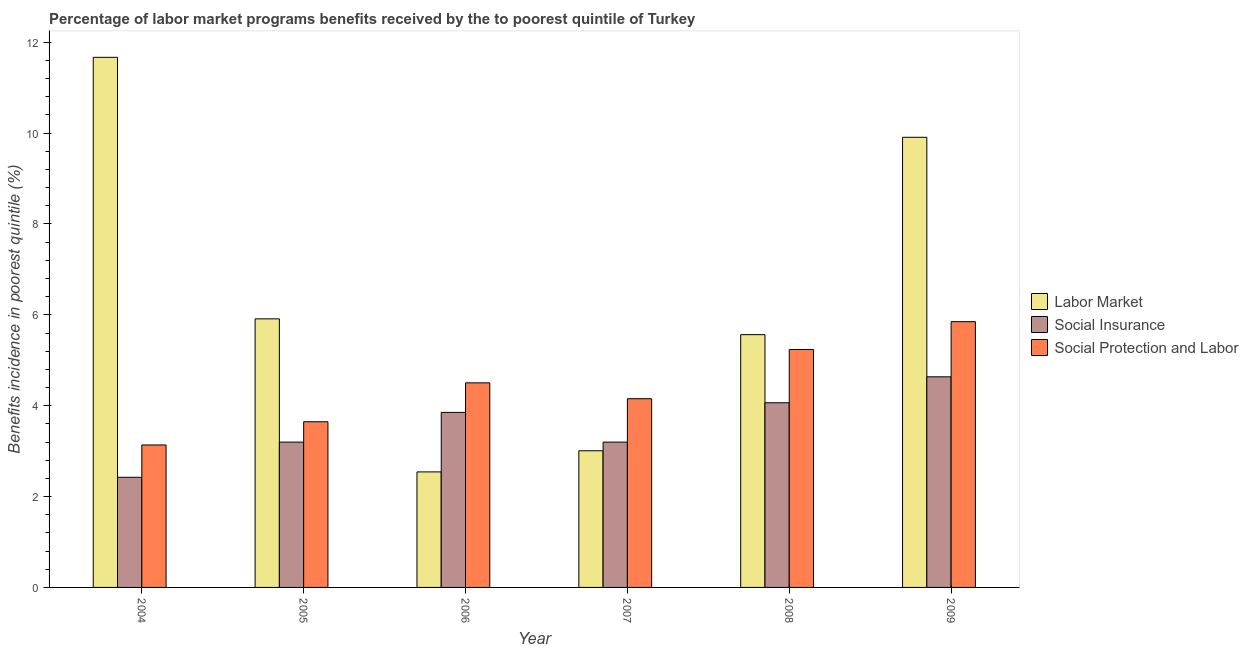How many different coloured bars are there?
Make the answer very short. 3. How many groups of bars are there?
Offer a very short reply. 6. Are the number of bars per tick equal to the number of legend labels?
Offer a terse response. Yes. In how many cases, is the number of bars for a given year not equal to the number of legend labels?
Your answer should be compact. 0. What is the percentage of benefits received due to social protection programs in 2006?
Provide a succinct answer. 4.5. Across all years, what is the maximum percentage of benefits received due to social protection programs?
Your response must be concise. 5.85. Across all years, what is the minimum percentage of benefits received due to labor market programs?
Your answer should be compact. 2.54. In which year was the percentage of benefits received due to social protection programs minimum?
Offer a terse response. 2004. What is the total percentage of benefits received due to labor market programs in the graph?
Provide a succinct answer. 38.6. What is the difference between the percentage of benefits received due to labor market programs in 2008 and that in 2009?
Provide a short and direct response. -4.34. What is the difference between the percentage of benefits received due to social insurance programs in 2006 and the percentage of benefits received due to social protection programs in 2005?
Keep it short and to the point. 0.65. What is the average percentage of benefits received due to social insurance programs per year?
Provide a succinct answer. 3.56. In the year 2006, what is the difference between the percentage of benefits received due to social insurance programs and percentage of benefits received due to social protection programs?
Your answer should be compact. 0. What is the ratio of the percentage of benefits received due to social protection programs in 2005 to that in 2006?
Make the answer very short. 0.81. Is the percentage of benefits received due to social insurance programs in 2006 less than that in 2007?
Provide a short and direct response. No. Is the difference between the percentage of benefits received due to social protection programs in 2005 and 2009 greater than the difference between the percentage of benefits received due to labor market programs in 2005 and 2009?
Keep it short and to the point. No. What is the difference between the highest and the second highest percentage of benefits received due to labor market programs?
Keep it short and to the point. 1.76. What is the difference between the highest and the lowest percentage of benefits received due to social protection programs?
Your response must be concise. 2.71. In how many years, is the percentage of benefits received due to social insurance programs greater than the average percentage of benefits received due to social insurance programs taken over all years?
Provide a short and direct response. 3. Is the sum of the percentage of benefits received due to social insurance programs in 2008 and 2009 greater than the maximum percentage of benefits received due to social protection programs across all years?
Offer a terse response. Yes. What does the 1st bar from the left in 2005 represents?
Give a very brief answer. Labor Market. What does the 3rd bar from the right in 2004 represents?
Your answer should be compact. Labor Market. Does the graph contain any zero values?
Your answer should be compact. No. Does the graph contain grids?
Your response must be concise. No. Where does the legend appear in the graph?
Make the answer very short. Center right. How many legend labels are there?
Keep it short and to the point. 3. What is the title of the graph?
Keep it short and to the point. Percentage of labor market programs benefits received by the to poorest quintile of Turkey. What is the label or title of the Y-axis?
Your answer should be very brief. Benefits incidence in poorest quintile (%). What is the Benefits incidence in poorest quintile (%) of Labor Market in 2004?
Provide a succinct answer. 11.67. What is the Benefits incidence in poorest quintile (%) in Social Insurance in 2004?
Ensure brevity in your answer.  2.42. What is the Benefits incidence in poorest quintile (%) of Social Protection and Labor in 2004?
Offer a very short reply. 3.14. What is the Benefits incidence in poorest quintile (%) of Labor Market in 2005?
Your answer should be compact. 5.91. What is the Benefits incidence in poorest quintile (%) in Social Insurance in 2005?
Offer a very short reply. 3.2. What is the Benefits incidence in poorest quintile (%) of Social Protection and Labor in 2005?
Make the answer very short. 3.65. What is the Benefits incidence in poorest quintile (%) in Labor Market in 2006?
Provide a short and direct response. 2.54. What is the Benefits incidence in poorest quintile (%) in Social Insurance in 2006?
Offer a very short reply. 3.85. What is the Benefits incidence in poorest quintile (%) in Social Protection and Labor in 2006?
Make the answer very short. 4.5. What is the Benefits incidence in poorest quintile (%) of Labor Market in 2007?
Provide a succinct answer. 3.01. What is the Benefits incidence in poorest quintile (%) in Social Insurance in 2007?
Offer a terse response. 3.2. What is the Benefits incidence in poorest quintile (%) of Social Protection and Labor in 2007?
Keep it short and to the point. 4.15. What is the Benefits incidence in poorest quintile (%) in Labor Market in 2008?
Provide a succinct answer. 5.56. What is the Benefits incidence in poorest quintile (%) of Social Insurance in 2008?
Offer a very short reply. 4.06. What is the Benefits incidence in poorest quintile (%) in Social Protection and Labor in 2008?
Give a very brief answer. 5.24. What is the Benefits incidence in poorest quintile (%) of Labor Market in 2009?
Offer a terse response. 9.91. What is the Benefits incidence in poorest quintile (%) in Social Insurance in 2009?
Offer a very short reply. 4.64. What is the Benefits incidence in poorest quintile (%) in Social Protection and Labor in 2009?
Provide a short and direct response. 5.85. Across all years, what is the maximum Benefits incidence in poorest quintile (%) of Labor Market?
Your answer should be compact. 11.67. Across all years, what is the maximum Benefits incidence in poorest quintile (%) in Social Insurance?
Provide a short and direct response. 4.64. Across all years, what is the maximum Benefits incidence in poorest quintile (%) of Social Protection and Labor?
Offer a very short reply. 5.85. Across all years, what is the minimum Benefits incidence in poorest quintile (%) in Labor Market?
Offer a very short reply. 2.54. Across all years, what is the minimum Benefits incidence in poorest quintile (%) in Social Insurance?
Your answer should be compact. 2.42. Across all years, what is the minimum Benefits incidence in poorest quintile (%) of Social Protection and Labor?
Ensure brevity in your answer.  3.14. What is the total Benefits incidence in poorest quintile (%) of Labor Market in the graph?
Ensure brevity in your answer.  38.6. What is the total Benefits incidence in poorest quintile (%) in Social Insurance in the graph?
Your answer should be very brief. 21.37. What is the total Benefits incidence in poorest quintile (%) in Social Protection and Labor in the graph?
Provide a succinct answer. 26.53. What is the difference between the Benefits incidence in poorest quintile (%) of Labor Market in 2004 and that in 2005?
Ensure brevity in your answer.  5.76. What is the difference between the Benefits incidence in poorest quintile (%) of Social Insurance in 2004 and that in 2005?
Give a very brief answer. -0.77. What is the difference between the Benefits incidence in poorest quintile (%) of Social Protection and Labor in 2004 and that in 2005?
Ensure brevity in your answer.  -0.51. What is the difference between the Benefits incidence in poorest quintile (%) in Labor Market in 2004 and that in 2006?
Make the answer very short. 9.13. What is the difference between the Benefits incidence in poorest quintile (%) in Social Insurance in 2004 and that in 2006?
Offer a very short reply. -1.43. What is the difference between the Benefits incidence in poorest quintile (%) of Social Protection and Labor in 2004 and that in 2006?
Ensure brevity in your answer.  -1.37. What is the difference between the Benefits incidence in poorest quintile (%) of Labor Market in 2004 and that in 2007?
Make the answer very short. 8.66. What is the difference between the Benefits incidence in poorest quintile (%) in Social Insurance in 2004 and that in 2007?
Your answer should be very brief. -0.77. What is the difference between the Benefits incidence in poorest quintile (%) of Social Protection and Labor in 2004 and that in 2007?
Keep it short and to the point. -1.02. What is the difference between the Benefits incidence in poorest quintile (%) of Labor Market in 2004 and that in 2008?
Provide a short and direct response. 6.11. What is the difference between the Benefits incidence in poorest quintile (%) in Social Insurance in 2004 and that in 2008?
Provide a short and direct response. -1.64. What is the difference between the Benefits incidence in poorest quintile (%) in Social Protection and Labor in 2004 and that in 2008?
Your answer should be very brief. -2.1. What is the difference between the Benefits incidence in poorest quintile (%) of Labor Market in 2004 and that in 2009?
Offer a terse response. 1.76. What is the difference between the Benefits incidence in poorest quintile (%) in Social Insurance in 2004 and that in 2009?
Provide a succinct answer. -2.21. What is the difference between the Benefits incidence in poorest quintile (%) in Social Protection and Labor in 2004 and that in 2009?
Keep it short and to the point. -2.71. What is the difference between the Benefits incidence in poorest quintile (%) of Labor Market in 2005 and that in 2006?
Keep it short and to the point. 3.37. What is the difference between the Benefits incidence in poorest quintile (%) in Social Insurance in 2005 and that in 2006?
Make the answer very short. -0.65. What is the difference between the Benefits incidence in poorest quintile (%) of Social Protection and Labor in 2005 and that in 2006?
Ensure brevity in your answer.  -0.86. What is the difference between the Benefits incidence in poorest quintile (%) in Labor Market in 2005 and that in 2007?
Your answer should be very brief. 2.9. What is the difference between the Benefits incidence in poorest quintile (%) in Social Insurance in 2005 and that in 2007?
Ensure brevity in your answer.  0. What is the difference between the Benefits incidence in poorest quintile (%) in Social Protection and Labor in 2005 and that in 2007?
Offer a very short reply. -0.51. What is the difference between the Benefits incidence in poorest quintile (%) of Labor Market in 2005 and that in 2008?
Offer a very short reply. 0.35. What is the difference between the Benefits incidence in poorest quintile (%) of Social Insurance in 2005 and that in 2008?
Make the answer very short. -0.87. What is the difference between the Benefits incidence in poorest quintile (%) of Social Protection and Labor in 2005 and that in 2008?
Give a very brief answer. -1.59. What is the difference between the Benefits incidence in poorest quintile (%) of Labor Market in 2005 and that in 2009?
Your answer should be compact. -4. What is the difference between the Benefits incidence in poorest quintile (%) of Social Insurance in 2005 and that in 2009?
Give a very brief answer. -1.44. What is the difference between the Benefits incidence in poorest quintile (%) in Social Protection and Labor in 2005 and that in 2009?
Keep it short and to the point. -2.2. What is the difference between the Benefits incidence in poorest quintile (%) of Labor Market in 2006 and that in 2007?
Give a very brief answer. -0.46. What is the difference between the Benefits incidence in poorest quintile (%) of Social Insurance in 2006 and that in 2007?
Make the answer very short. 0.65. What is the difference between the Benefits incidence in poorest quintile (%) in Social Protection and Labor in 2006 and that in 2007?
Give a very brief answer. 0.35. What is the difference between the Benefits incidence in poorest quintile (%) in Labor Market in 2006 and that in 2008?
Your response must be concise. -3.02. What is the difference between the Benefits incidence in poorest quintile (%) in Social Insurance in 2006 and that in 2008?
Ensure brevity in your answer.  -0.21. What is the difference between the Benefits incidence in poorest quintile (%) in Social Protection and Labor in 2006 and that in 2008?
Make the answer very short. -0.73. What is the difference between the Benefits incidence in poorest quintile (%) of Labor Market in 2006 and that in 2009?
Provide a succinct answer. -7.37. What is the difference between the Benefits incidence in poorest quintile (%) of Social Insurance in 2006 and that in 2009?
Ensure brevity in your answer.  -0.78. What is the difference between the Benefits incidence in poorest quintile (%) of Social Protection and Labor in 2006 and that in 2009?
Your answer should be very brief. -1.35. What is the difference between the Benefits incidence in poorest quintile (%) of Labor Market in 2007 and that in 2008?
Ensure brevity in your answer.  -2.56. What is the difference between the Benefits incidence in poorest quintile (%) in Social Insurance in 2007 and that in 2008?
Keep it short and to the point. -0.87. What is the difference between the Benefits incidence in poorest quintile (%) in Social Protection and Labor in 2007 and that in 2008?
Keep it short and to the point. -1.08. What is the difference between the Benefits incidence in poorest quintile (%) in Labor Market in 2007 and that in 2009?
Give a very brief answer. -6.9. What is the difference between the Benefits incidence in poorest quintile (%) of Social Insurance in 2007 and that in 2009?
Your response must be concise. -1.44. What is the difference between the Benefits incidence in poorest quintile (%) of Social Protection and Labor in 2007 and that in 2009?
Offer a very short reply. -1.7. What is the difference between the Benefits incidence in poorest quintile (%) in Labor Market in 2008 and that in 2009?
Your answer should be very brief. -4.34. What is the difference between the Benefits incidence in poorest quintile (%) in Social Insurance in 2008 and that in 2009?
Your response must be concise. -0.57. What is the difference between the Benefits incidence in poorest quintile (%) of Social Protection and Labor in 2008 and that in 2009?
Provide a succinct answer. -0.61. What is the difference between the Benefits incidence in poorest quintile (%) of Labor Market in 2004 and the Benefits incidence in poorest quintile (%) of Social Insurance in 2005?
Provide a succinct answer. 8.47. What is the difference between the Benefits incidence in poorest quintile (%) in Labor Market in 2004 and the Benefits incidence in poorest quintile (%) in Social Protection and Labor in 2005?
Keep it short and to the point. 8.02. What is the difference between the Benefits incidence in poorest quintile (%) in Social Insurance in 2004 and the Benefits incidence in poorest quintile (%) in Social Protection and Labor in 2005?
Offer a very short reply. -1.22. What is the difference between the Benefits incidence in poorest quintile (%) of Labor Market in 2004 and the Benefits incidence in poorest quintile (%) of Social Insurance in 2006?
Keep it short and to the point. 7.82. What is the difference between the Benefits incidence in poorest quintile (%) in Labor Market in 2004 and the Benefits incidence in poorest quintile (%) in Social Protection and Labor in 2006?
Your answer should be compact. 7.17. What is the difference between the Benefits incidence in poorest quintile (%) in Social Insurance in 2004 and the Benefits incidence in poorest quintile (%) in Social Protection and Labor in 2006?
Provide a short and direct response. -2.08. What is the difference between the Benefits incidence in poorest quintile (%) of Labor Market in 2004 and the Benefits incidence in poorest quintile (%) of Social Insurance in 2007?
Your response must be concise. 8.47. What is the difference between the Benefits incidence in poorest quintile (%) in Labor Market in 2004 and the Benefits incidence in poorest quintile (%) in Social Protection and Labor in 2007?
Your answer should be compact. 7.51. What is the difference between the Benefits incidence in poorest quintile (%) in Social Insurance in 2004 and the Benefits incidence in poorest quintile (%) in Social Protection and Labor in 2007?
Keep it short and to the point. -1.73. What is the difference between the Benefits incidence in poorest quintile (%) in Labor Market in 2004 and the Benefits incidence in poorest quintile (%) in Social Insurance in 2008?
Ensure brevity in your answer.  7.6. What is the difference between the Benefits incidence in poorest quintile (%) of Labor Market in 2004 and the Benefits incidence in poorest quintile (%) of Social Protection and Labor in 2008?
Make the answer very short. 6.43. What is the difference between the Benefits incidence in poorest quintile (%) of Social Insurance in 2004 and the Benefits incidence in poorest quintile (%) of Social Protection and Labor in 2008?
Ensure brevity in your answer.  -2.81. What is the difference between the Benefits incidence in poorest quintile (%) of Labor Market in 2004 and the Benefits incidence in poorest quintile (%) of Social Insurance in 2009?
Provide a succinct answer. 7.03. What is the difference between the Benefits incidence in poorest quintile (%) in Labor Market in 2004 and the Benefits incidence in poorest quintile (%) in Social Protection and Labor in 2009?
Provide a succinct answer. 5.82. What is the difference between the Benefits incidence in poorest quintile (%) in Social Insurance in 2004 and the Benefits incidence in poorest quintile (%) in Social Protection and Labor in 2009?
Your answer should be compact. -3.43. What is the difference between the Benefits incidence in poorest quintile (%) in Labor Market in 2005 and the Benefits incidence in poorest quintile (%) in Social Insurance in 2006?
Provide a short and direct response. 2.06. What is the difference between the Benefits incidence in poorest quintile (%) in Labor Market in 2005 and the Benefits incidence in poorest quintile (%) in Social Protection and Labor in 2006?
Your answer should be very brief. 1.41. What is the difference between the Benefits incidence in poorest quintile (%) in Social Insurance in 2005 and the Benefits incidence in poorest quintile (%) in Social Protection and Labor in 2006?
Ensure brevity in your answer.  -1.3. What is the difference between the Benefits incidence in poorest quintile (%) in Labor Market in 2005 and the Benefits incidence in poorest quintile (%) in Social Insurance in 2007?
Your response must be concise. 2.71. What is the difference between the Benefits incidence in poorest quintile (%) of Labor Market in 2005 and the Benefits incidence in poorest quintile (%) of Social Protection and Labor in 2007?
Ensure brevity in your answer.  1.76. What is the difference between the Benefits incidence in poorest quintile (%) in Social Insurance in 2005 and the Benefits incidence in poorest quintile (%) in Social Protection and Labor in 2007?
Your answer should be very brief. -0.96. What is the difference between the Benefits incidence in poorest quintile (%) in Labor Market in 2005 and the Benefits incidence in poorest quintile (%) in Social Insurance in 2008?
Provide a short and direct response. 1.85. What is the difference between the Benefits incidence in poorest quintile (%) in Labor Market in 2005 and the Benefits incidence in poorest quintile (%) in Social Protection and Labor in 2008?
Provide a short and direct response. 0.68. What is the difference between the Benefits incidence in poorest quintile (%) in Social Insurance in 2005 and the Benefits incidence in poorest quintile (%) in Social Protection and Labor in 2008?
Provide a succinct answer. -2.04. What is the difference between the Benefits incidence in poorest quintile (%) in Labor Market in 2005 and the Benefits incidence in poorest quintile (%) in Social Insurance in 2009?
Provide a short and direct response. 1.28. What is the difference between the Benefits incidence in poorest quintile (%) of Labor Market in 2005 and the Benefits incidence in poorest quintile (%) of Social Protection and Labor in 2009?
Provide a succinct answer. 0.06. What is the difference between the Benefits incidence in poorest quintile (%) in Social Insurance in 2005 and the Benefits incidence in poorest quintile (%) in Social Protection and Labor in 2009?
Ensure brevity in your answer.  -2.65. What is the difference between the Benefits incidence in poorest quintile (%) of Labor Market in 2006 and the Benefits incidence in poorest quintile (%) of Social Insurance in 2007?
Offer a very short reply. -0.66. What is the difference between the Benefits incidence in poorest quintile (%) in Labor Market in 2006 and the Benefits incidence in poorest quintile (%) in Social Protection and Labor in 2007?
Ensure brevity in your answer.  -1.61. What is the difference between the Benefits incidence in poorest quintile (%) in Social Insurance in 2006 and the Benefits incidence in poorest quintile (%) in Social Protection and Labor in 2007?
Offer a very short reply. -0.3. What is the difference between the Benefits incidence in poorest quintile (%) in Labor Market in 2006 and the Benefits incidence in poorest quintile (%) in Social Insurance in 2008?
Provide a succinct answer. -1.52. What is the difference between the Benefits incidence in poorest quintile (%) of Labor Market in 2006 and the Benefits incidence in poorest quintile (%) of Social Protection and Labor in 2008?
Your response must be concise. -2.69. What is the difference between the Benefits incidence in poorest quintile (%) of Social Insurance in 2006 and the Benefits incidence in poorest quintile (%) of Social Protection and Labor in 2008?
Ensure brevity in your answer.  -1.38. What is the difference between the Benefits incidence in poorest quintile (%) in Labor Market in 2006 and the Benefits incidence in poorest quintile (%) in Social Insurance in 2009?
Give a very brief answer. -2.09. What is the difference between the Benefits incidence in poorest quintile (%) of Labor Market in 2006 and the Benefits incidence in poorest quintile (%) of Social Protection and Labor in 2009?
Your answer should be compact. -3.31. What is the difference between the Benefits incidence in poorest quintile (%) of Social Insurance in 2006 and the Benefits incidence in poorest quintile (%) of Social Protection and Labor in 2009?
Keep it short and to the point. -2. What is the difference between the Benefits incidence in poorest quintile (%) of Labor Market in 2007 and the Benefits incidence in poorest quintile (%) of Social Insurance in 2008?
Give a very brief answer. -1.06. What is the difference between the Benefits incidence in poorest quintile (%) of Labor Market in 2007 and the Benefits incidence in poorest quintile (%) of Social Protection and Labor in 2008?
Your response must be concise. -2.23. What is the difference between the Benefits incidence in poorest quintile (%) of Social Insurance in 2007 and the Benefits incidence in poorest quintile (%) of Social Protection and Labor in 2008?
Provide a succinct answer. -2.04. What is the difference between the Benefits incidence in poorest quintile (%) in Labor Market in 2007 and the Benefits incidence in poorest quintile (%) in Social Insurance in 2009?
Your answer should be compact. -1.63. What is the difference between the Benefits incidence in poorest quintile (%) in Labor Market in 2007 and the Benefits incidence in poorest quintile (%) in Social Protection and Labor in 2009?
Offer a terse response. -2.84. What is the difference between the Benefits incidence in poorest quintile (%) in Social Insurance in 2007 and the Benefits incidence in poorest quintile (%) in Social Protection and Labor in 2009?
Your answer should be compact. -2.65. What is the difference between the Benefits incidence in poorest quintile (%) in Labor Market in 2008 and the Benefits incidence in poorest quintile (%) in Social Insurance in 2009?
Your answer should be very brief. 0.93. What is the difference between the Benefits incidence in poorest quintile (%) in Labor Market in 2008 and the Benefits incidence in poorest quintile (%) in Social Protection and Labor in 2009?
Provide a short and direct response. -0.29. What is the difference between the Benefits incidence in poorest quintile (%) of Social Insurance in 2008 and the Benefits incidence in poorest quintile (%) of Social Protection and Labor in 2009?
Ensure brevity in your answer.  -1.79. What is the average Benefits incidence in poorest quintile (%) of Labor Market per year?
Give a very brief answer. 6.43. What is the average Benefits incidence in poorest quintile (%) of Social Insurance per year?
Make the answer very short. 3.56. What is the average Benefits incidence in poorest quintile (%) of Social Protection and Labor per year?
Your response must be concise. 4.42. In the year 2004, what is the difference between the Benefits incidence in poorest quintile (%) of Labor Market and Benefits incidence in poorest quintile (%) of Social Insurance?
Ensure brevity in your answer.  9.24. In the year 2004, what is the difference between the Benefits incidence in poorest quintile (%) of Labor Market and Benefits incidence in poorest quintile (%) of Social Protection and Labor?
Give a very brief answer. 8.53. In the year 2004, what is the difference between the Benefits incidence in poorest quintile (%) of Social Insurance and Benefits incidence in poorest quintile (%) of Social Protection and Labor?
Ensure brevity in your answer.  -0.71. In the year 2005, what is the difference between the Benefits incidence in poorest quintile (%) in Labor Market and Benefits incidence in poorest quintile (%) in Social Insurance?
Make the answer very short. 2.71. In the year 2005, what is the difference between the Benefits incidence in poorest quintile (%) in Labor Market and Benefits incidence in poorest quintile (%) in Social Protection and Labor?
Your answer should be compact. 2.27. In the year 2005, what is the difference between the Benefits incidence in poorest quintile (%) in Social Insurance and Benefits incidence in poorest quintile (%) in Social Protection and Labor?
Provide a short and direct response. -0.45. In the year 2006, what is the difference between the Benefits incidence in poorest quintile (%) in Labor Market and Benefits incidence in poorest quintile (%) in Social Insurance?
Your response must be concise. -1.31. In the year 2006, what is the difference between the Benefits incidence in poorest quintile (%) in Labor Market and Benefits incidence in poorest quintile (%) in Social Protection and Labor?
Provide a short and direct response. -1.96. In the year 2006, what is the difference between the Benefits incidence in poorest quintile (%) in Social Insurance and Benefits incidence in poorest quintile (%) in Social Protection and Labor?
Give a very brief answer. -0.65. In the year 2007, what is the difference between the Benefits incidence in poorest quintile (%) of Labor Market and Benefits incidence in poorest quintile (%) of Social Insurance?
Provide a succinct answer. -0.19. In the year 2007, what is the difference between the Benefits incidence in poorest quintile (%) of Labor Market and Benefits incidence in poorest quintile (%) of Social Protection and Labor?
Keep it short and to the point. -1.15. In the year 2007, what is the difference between the Benefits incidence in poorest quintile (%) in Social Insurance and Benefits incidence in poorest quintile (%) in Social Protection and Labor?
Provide a succinct answer. -0.96. In the year 2008, what is the difference between the Benefits incidence in poorest quintile (%) of Labor Market and Benefits incidence in poorest quintile (%) of Social Insurance?
Ensure brevity in your answer.  1.5. In the year 2008, what is the difference between the Benefits incidence in poorest quintile (%) in Labor Market and Benefits incidence in poorest quintile (%) in Social Protection and Labor?
Provide a succinct answer. 0.33. In the year 2008, what is the difference between the Benefits incidence in poorest quintile (%) of Social Insurance and Benefits incidence in poorest quintile (%) of Social Protection and Labor?
Your answer should be very brief. -1.17. In the year 2009, what is the difference between the Benefits incidence in poorest quintile (%) of Labor Market and Benefits incidence in poorest quintile (%) of Social Insurance?
Give a very brief answer. 5.27. In the year 2009, what is the difference between the Benefits incidence in poorest quintile (%) of Labor Market and Benefits incidence in poorest quintile (%) of Social Protection and Labor?
Your answer should be very brief. 4.06. In the year 2009, what is the difference between the Benefits incidence in poorest quintile (%) in Social Insurance and Benefits incidence in poorest quintile (%) in Social Protection and Labor?
Ensure brevity in your answer.  -1.21. What is the ratio of the Benefits incidence in poorest quintile (%) of Labor Market in 2004 to that in 2005?
Your response must be concise. 1.97. What is the ratio of the Benefits incidence in poorest quintile (%) in Social Insurance in 2004 to that in 2005?
Your answer should be compact. 0.76. What is the ratio of the Benefits incidence in poorest quintile (%) of Social Protection and Labor in 2004 to that in 2005?
Provide a succinct answer. 0.86. What is the ratio of the Benefits incidence in poorest quintile (%) in Labor Market in 2004 to that in 2006?
Keep it short and to the point. 4.59. What is the ratio of the Benefits incidence in poorest quintile (%) of Social Insurance in 2004 to that in 2006?
Offer a very short reply. 0.63. What is the ratio of the Benefits incidence in poorest quintile (%) in Social Protection and Labor in 2004 to that in 2006?
Your answer should be compact. 0.7. What is the ratio of the Benefits incidence in poorest quintile (%) in Labor Market in 2004 to that in 2007?
Give a very brief answer. 3.88. What is the ratio of the Benefits incidence in poorest quintile (%) of Social Insurance in 2004 to that in 2007?
Your answer should be compact. 0.76. What is the ratio of the Benefits incidence in poorest quintile (%) in Social Protection and Labor in 2004 to that in 2007?
Provide a short and direct response. 0.76. What is the ratio of the Benefits incidence in poorest quintile (%) of Labor Market in 2004 to that in 2008?
Provide a succinct answer. 2.1. What is the ratio of the Benefits incidence in poorest quintile (%) in Social Insurance in 2004 to that in 2008?
Your answer should be very brief. 0.6. What is the ratio of the Benefits incidence in poorest quintile (%) in Social Protection and Labor in 2004 to that in 2008?
Keep it short and to the point. 0.6. What is the ratio of the Benefits incidence in poorest quintile (%) in Labor Market in 2004 to that in 2009?
Make the answer very short. 1.18. What is the ratio of the Benefits incidence in poorest quintile (%) in Social Insurance in 2004 to that in 2009?
Keep it short and to the point. 0.52. What is the ratio of the Benefits incidence in poorest quintile (%) in Social Protection and Labor in 2004 to that in 2009?
Your response must be concise. 0.54. What is the ratio of the Benefits incidence in poorest quintile (%) of Labor Market in 2005 to that in 2006?
Provide a succinct answer. 2.32. What is the ratio of the Benefits incidence in poorest quintile (%) in Social Insurance in 2005 to that in 2006?
Offer a terse response. 0.83. What is the ratio of the Benefits incidence in poorest quintile (%) in Social Protection and Labor in 2005 to that in 2006?
Offer a terse response. 0.81. What is the ratio of the Benefits incidence in poorest quintile (%) of Labor Market in 2005 to that in 2007?
Your response must be concise. 1.97. What is the ratio of the Benefits incidence in poorest quintile (%) in Social Insurance in 2005 to that in 2007?
Provide a succinct answer. 1. What is the ratio of the Benefits incidence in poorest quintile (%) in Social Protection and Labor in 2005 to that in 2007?
Offer a terse response. 0.88. What is the ratio of the Benefits incidence in poorest quintile (%) of Labor Market in 2005 to that in 2008?
Give a very brief answer. 1.06. What is the ratio of the Benefits incidence in poorest quintile (%) of Social Insurance in 2005 to that in 2008?
Provide a short and direct response. 0.79. What is the ratio of the Benefits incidence in poorest quintile (%) of Social Protection and Labor in 2005 to that in 2008?
Provide a succinct answer. 0.7. What is the ratio of the Benefits incidence in poorest quintile (%) of Labor Market in 2005 to that in 2009?
Ensure brevity in your answer.  0.6. What is the ratio of the Benefits incidence in poorest quintile (%) of Social Insurance in 2005 to that in 2009?
Offer a terse response. 0.69. What is the ratio of the Benefits incidence in poorest quintile (%) in Social Protection and Labor in 2005 to that in 2009?
Keep it short and to the point. 0.62. What is the ratio of the Benefits incidence in poorest quintile (%) of Labor Market in 2006 to that in 2007?
Provide a succinct answer. 0.85. What is the ratio of the Benefits incidence in poorest quintile (%) of Social Insurance in 2006 to that in 2007?
Your answer should be very brief. 1.2. What is the ratio of the Benefits incidence in poorest quintile (%) in Social Protection and Labor in 2006 to that in 2007?
Offer a very short reply. 1.08. What is the ratio of the Benefits incidence in poorest quintile (%) in Labor Market in 2006 to that in 2008?
Give a very brief answer. 0.46. What is the ratio of the Benefits incidence in poorest quintile (%) of Social Insurance in 2006 to that in 2008?
Ensure brevity in your answer.  0.95. What is the ratio of the Benefits incidence in poorest quintile (%) of Social Protection and Labor in 2006 to that in 2008?
Your response must be concise. 0.86. What is the ratio of the Benefits incidence in poorest quintile (%) in Labor Market in 2006 to that in 2009?
Offer a terse response. 0.26. What is the ratio of the Benefits incidence in poorest quintile (%) in Social Insurance in 2006 to that in 2009?
Offer a terse response. 0.83. What is the ratio of the Benefits incidence in poorest quintile (%) in Social Protection and Labor in 2006 to that in 2009?
Your answer should be compact. 0.77. What is the ratio of the Benefits incidence in poorest quintile (%) of Labor Market in 2007 to that in 2008?
Offer a very short reply. 0.54. What is the ratio of the Benefits incidence in poorest quintile (%) in Social Insurance in 2007 to that in 2008?
Your answer should be very brief. 0.79. What is the ratio of the Benefits incidence in poorest quintile (%) in Social Protection and Labor in 2007 to that in 2008?
Keep it short and to the point. 0.79. What is the ratio of the Benefits incidence in poorest quintile (%) of Labor Market in 2007 to that in 2009?
Provide a succinct answer. 0.3. What is the ratio of the Benefits incidence in poorest quintile (%) in Social Insurance in 2007 to that in 2009?
Your answer should be compact. 0.69. What is the ratio of the Benefits incidence in poorest quintile (%) of Social Protection and Labor in 2007 to that in 2009?
Provide a short and direct response. 0.71. What is the ratio of the Benefits incidence in poorest quintile (%) in Labor Market in 2008 to that in 2009?
Make the answer very short. 0.56. What is the ratio of the Benefits incidence in poorest quintile (%) of Social Insurance in 2008 to that in 2009?
Ensure brevity in your answer.  0.88. What is the ratio of the Benefits incidence in poorest quintile (%) in Social Protection and Labor in 2008 to that in 2009?
Provide a short and direct response. 0.9. What is the difference between the highest and the second highest Benefits incidence in poorest quintile (%) of Labor Market?
Keep it short and to the point. 1.76. What is the difference between the highest and the second highest Benefits incidence in poorest quintile (%) in Social Protection and Labor?
Keep it short and to the point. 0.61. What is the difference between the highest and the lowest Benefits incidence in poorest quintile (%) of Labor Market?
Offer a very short reply. 9.13. What is the difference between the highest and the lowest Benefits incidence in poorest quintile (%) in Social Insurance?
Your answer should be very brief. 2.21. What is the difference between the highest and the lowest Benefits incidence in poorest quintile (%) in Social Protection and Labor?
Provide a succinct answer. 2.71. 